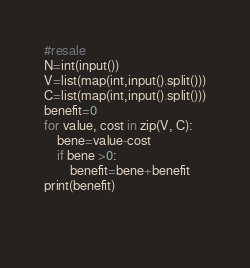Convert code to text. <code><loc_0><loc_0><loc_500><loc_500><_Python_>#resale
N=int(input())
V=list(map(int,input().split()))
C=list(map(int,input().split()))
benefit=0
for value, cost in zip(V, C):
    bene=value-cost
    if bene >0:
        benefit=bene+benefit
print(benefit)
        
    </code> 